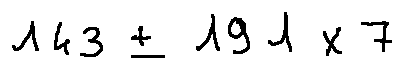<formula> <loc_0><loc_0><loc_500><loc_500>1 4 3 \pm 1 9 1 \times 7</formula> 